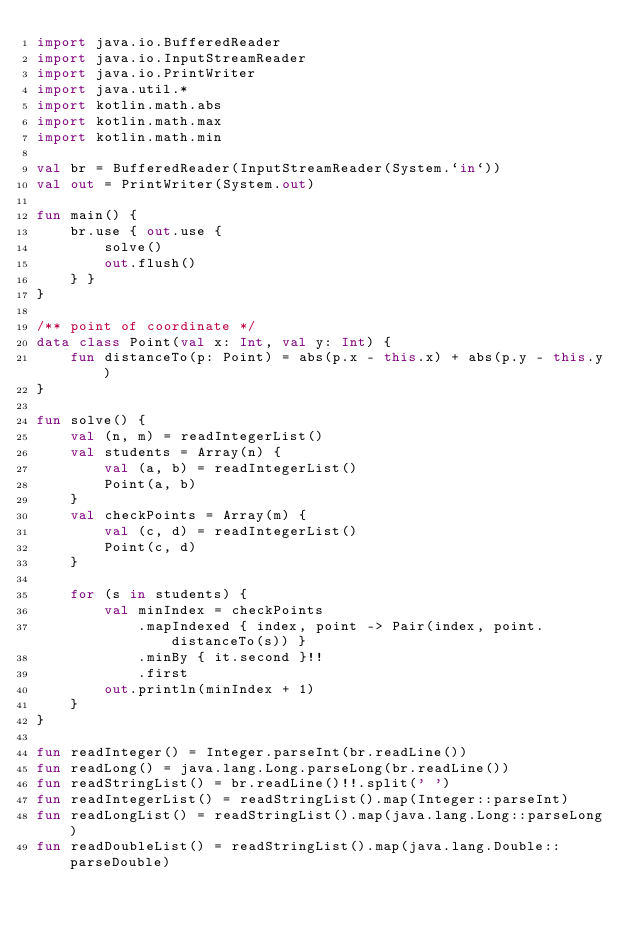Convert code to text. <code><loc_0><loc_0><loc_500><loc_500><_Kotlin_>import java.io.BufferedReader
import java.io.InputStreamReader
import java.io.PrintWriter
import java.util.*
import kotlin.math.abs
import kotlin.math.max
import kotlin.math.min

val br = BufferedReader(InputStreamReader(System.`in`))
val out = PrintWriter(System.out)

fun main() {
    br.use { out.use {
        solve()
        out.flush()
    } }
}

/** point of coordinate */
data class Point(val x: Int, val y: Int) {
    fun distanceTo(p: Point) = abs(p.x - this.x) + abs(p.y - this.y)
}

fun solve() {
    val (n, m) = readIntegerList()
    val students = Array(n) {
        val (a, b) = readIntegerList()
        Point(a, b)
    }
    val checkPoints = Array(m) {
        val (c, d) = readIntegerList()
        Point(c, d)
    }

    for (s in students) {
        val minIndex = checkPoints
            .mapIndexed { index, point -> Pair(index, point.distanceTo(s)) }
            .minBy { it.second }!!
            .first
        out.println(minIndex + 1)
    }
}

fun readInteger() = Integer.parseInt(br.readLine())
fun readLong() = java.lang.Long.parseLong(br.readLine())
fun readStringList() = br.readLine()!!.split(' ')
fun readIntegerList() = readStringList().map(Integer::parseInt)
fun readLongList() = readStringList().map(java.lang.Long::parseLong)
fun readDoubleList() = readStringList().map(java.lang.Double::parseDouble)
</code> 